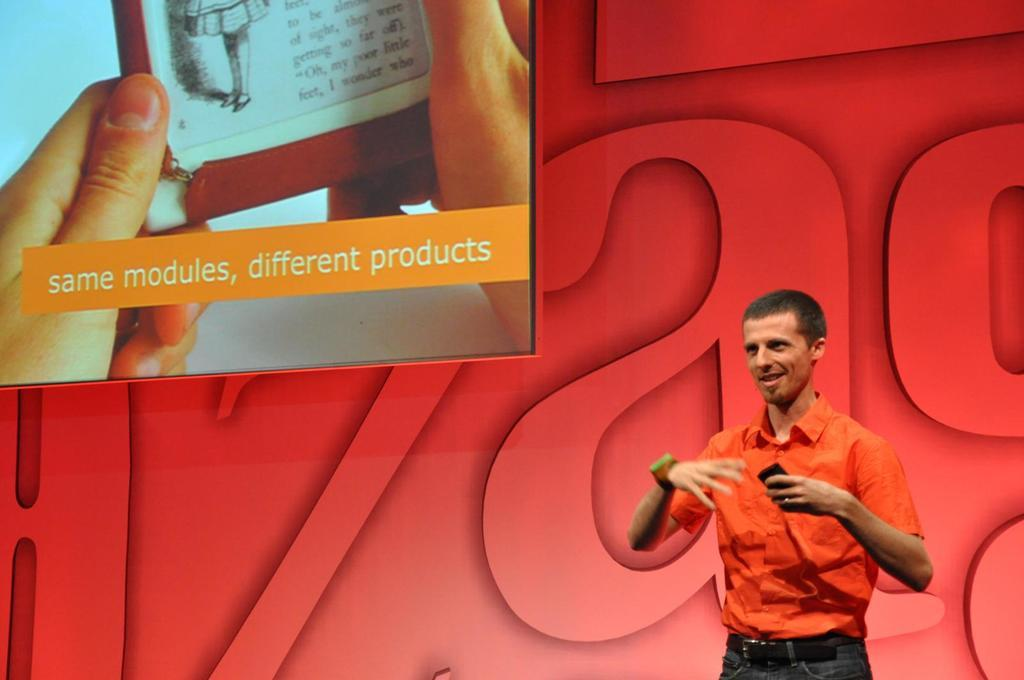<image>
Relay a brief, clear account of the picture shown. An advertisement on a screen says same modules, different products. 